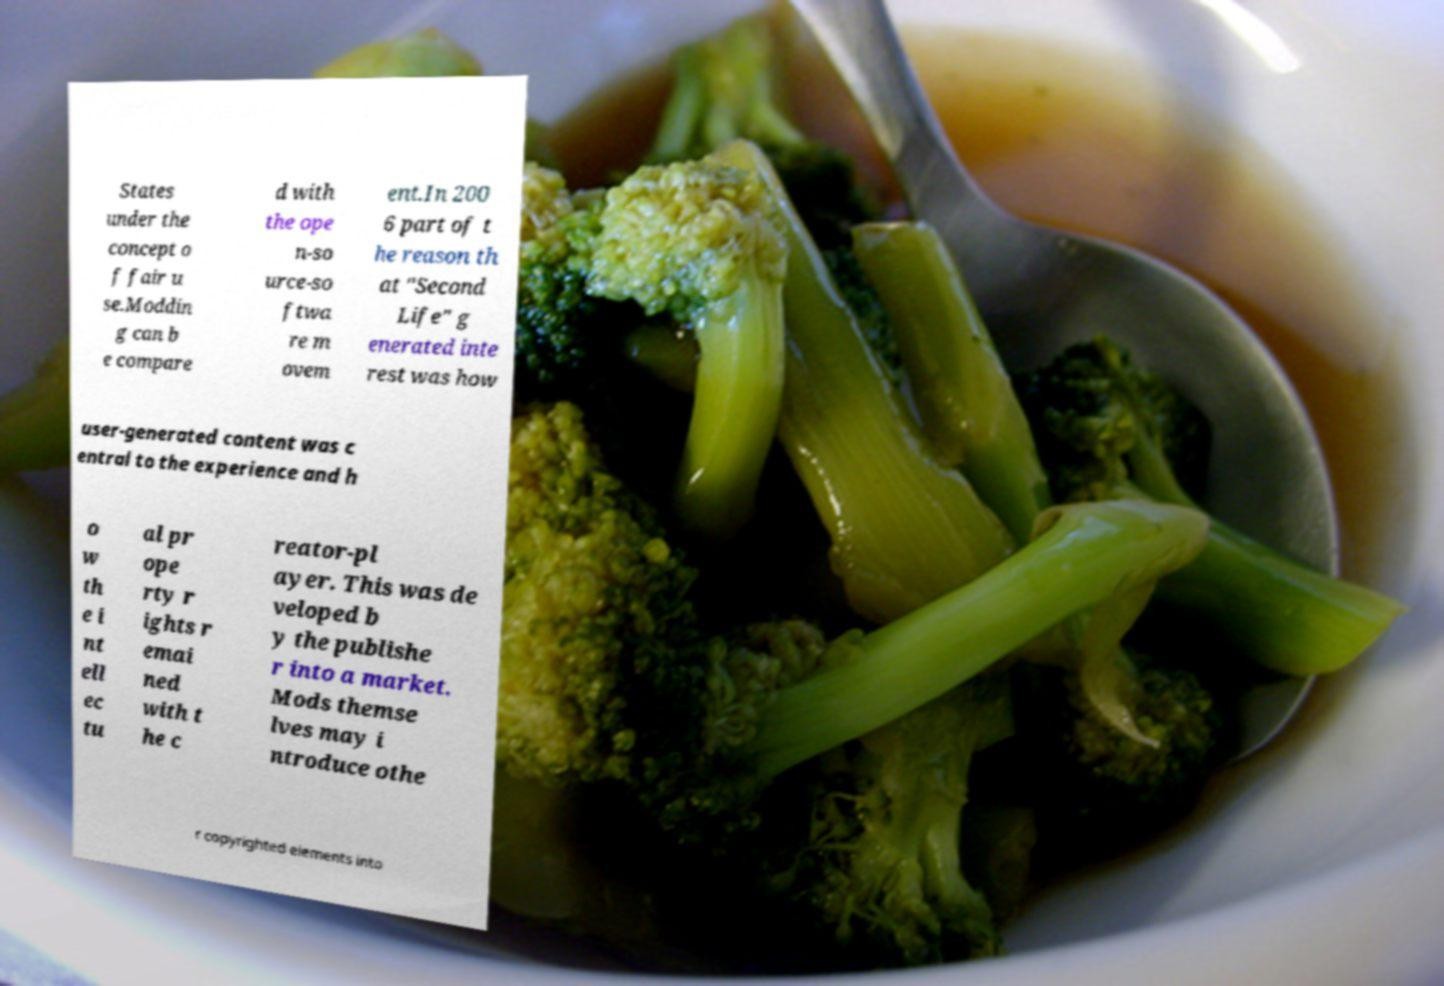For documentation purposes, I need the text within this image transcribed. Could you provide that? States under the concept o f fair u se.Moddin g can b e compare d with the ope n-so urce-so ftwa re m ovem ent.In 200 6 part of t he reason th at "Second Life" g enerated inte rest was how user-generated content was c entral to the experience and h o w th e i nt ell ec tu al pr ope rty r ights r emai ned with t he c reator-pl ayer. This was de veloped b y the publishe r into a market. Mods themse lves may i ntroduce othe r copyrighted elements into 